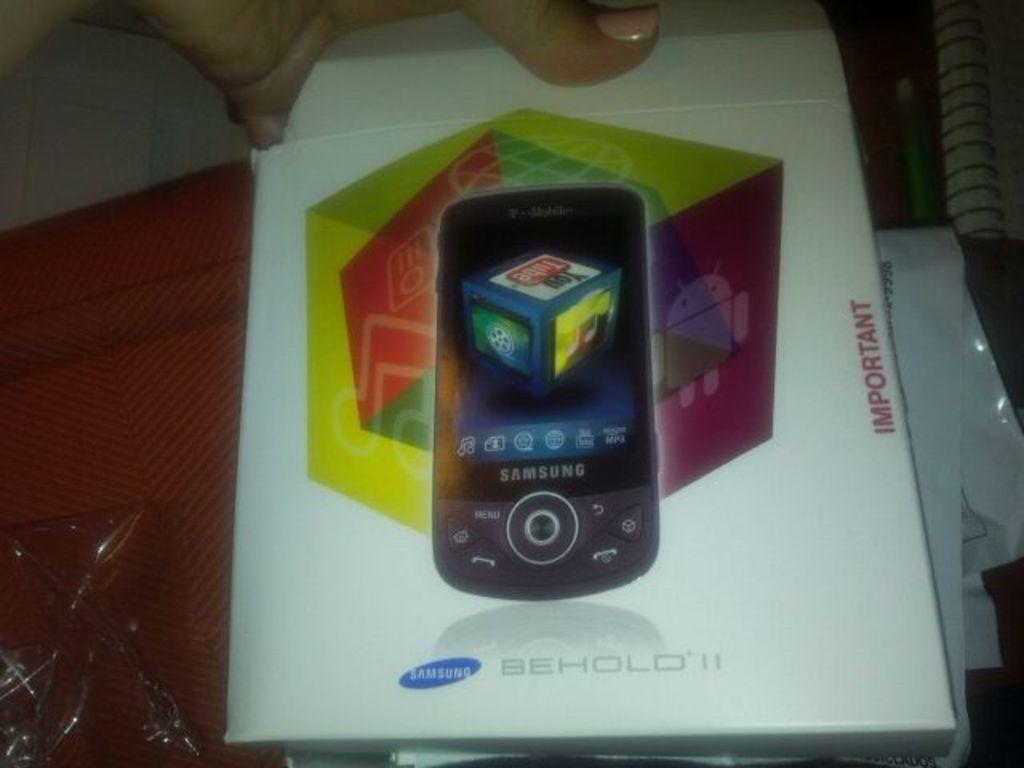Provide a one-sentence caption for the provided image. A Samsung brand phone is called Behold 11. 